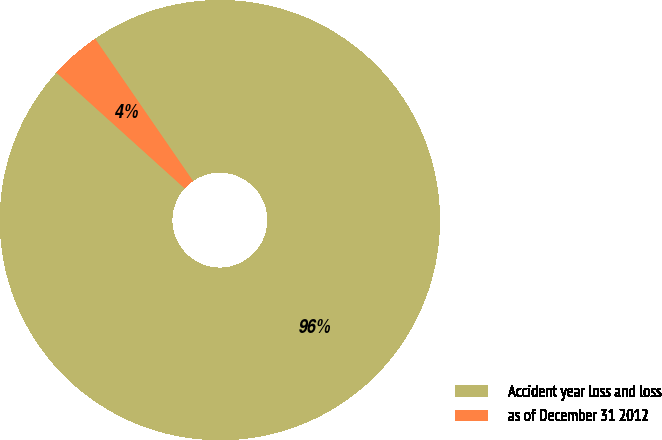<chart> <loc_0><loc_0><loc_500><loc_500><pie_chart><fcel>Accident year loss and loss<fcel>as of December 31 2012<nl><fcel>96.28%<fcel>3.72%<nl></chart> 